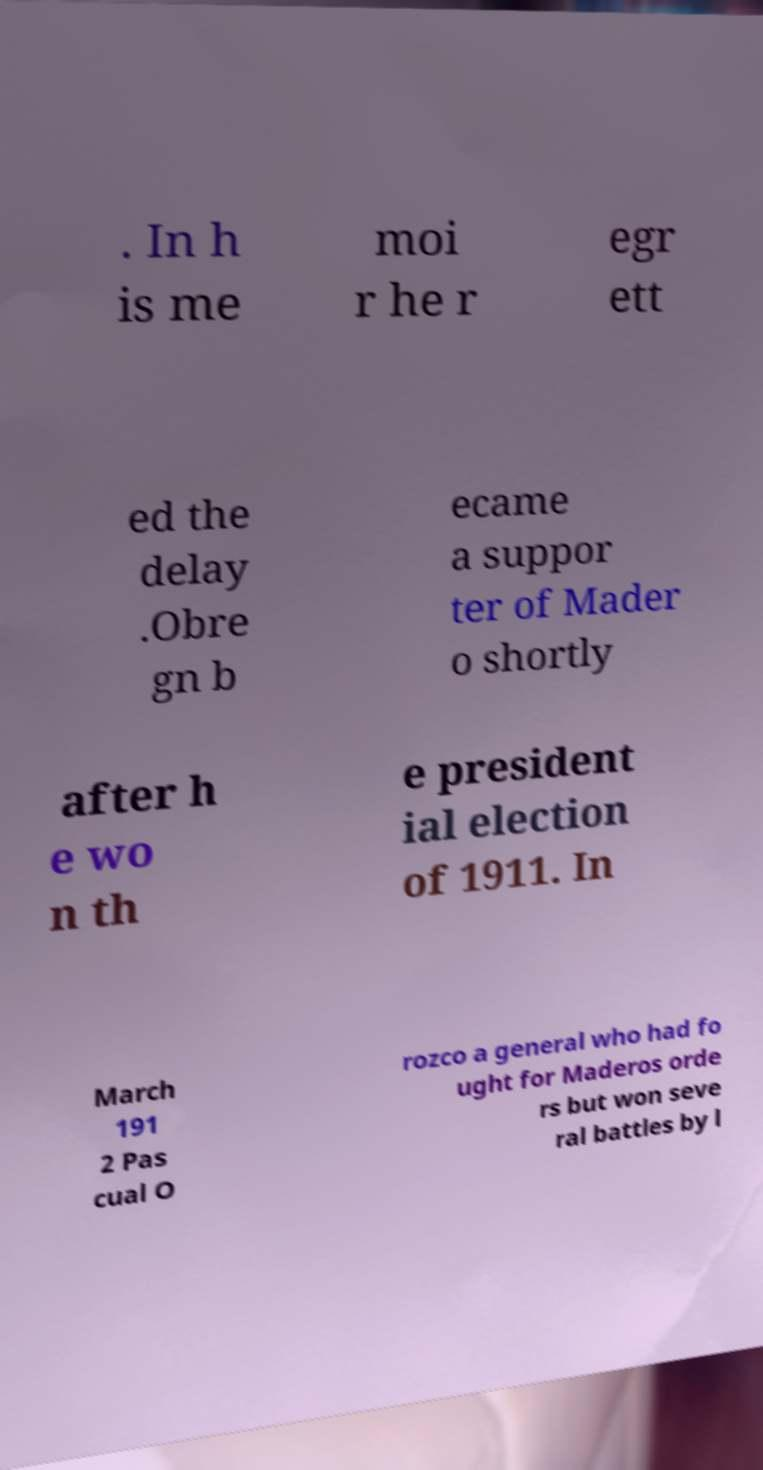Could you assist in decoding the text presented in this image and type it out clearly? . In h is me moi r he r egr ett ed the delay .Obre gn b ecame a suppor ter of Mader o shortly after h e wo n th e president ial election of 1911. In March 191 2 Pas cual O rozco a general who had fo ught for Maderos orde rs but won seve ral battles by l 